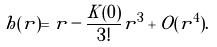Convert formula to latex. <formula><loc_0><loc_0><loc_500><loc_500>h ( r ) = r - \frac { K ( 0 ) } { 3 ! } r ^ { 3 } + O ( r ^ { 4 } ) .</formula> 